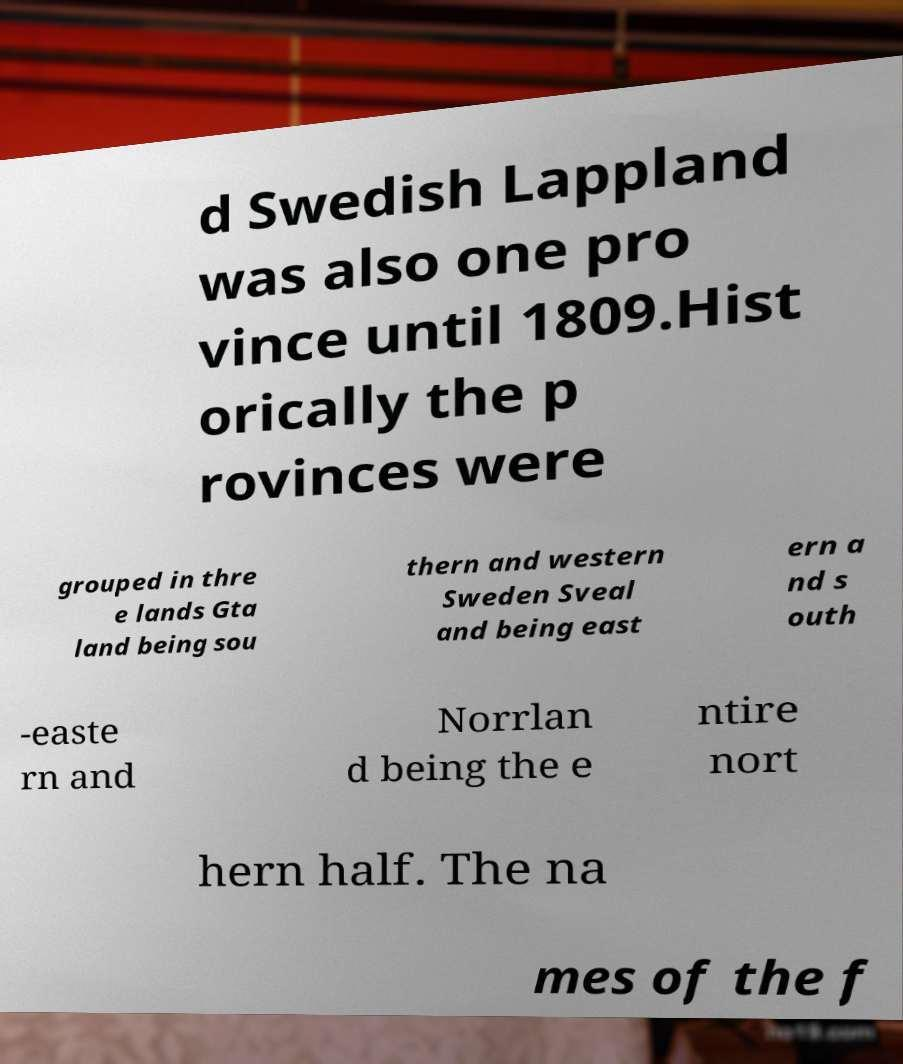Please read and relay the text visible in this image. What does it say? d Swedish Lappland was also one pro vince until 1809.Hist orically the p rovinces were grouped in thre e lands Gta land being sou thern and western Sweden Sveal and being east ern a nd s outh -easte rn and Norrlan d being the e ntire nort hern half. The na mes of the f 